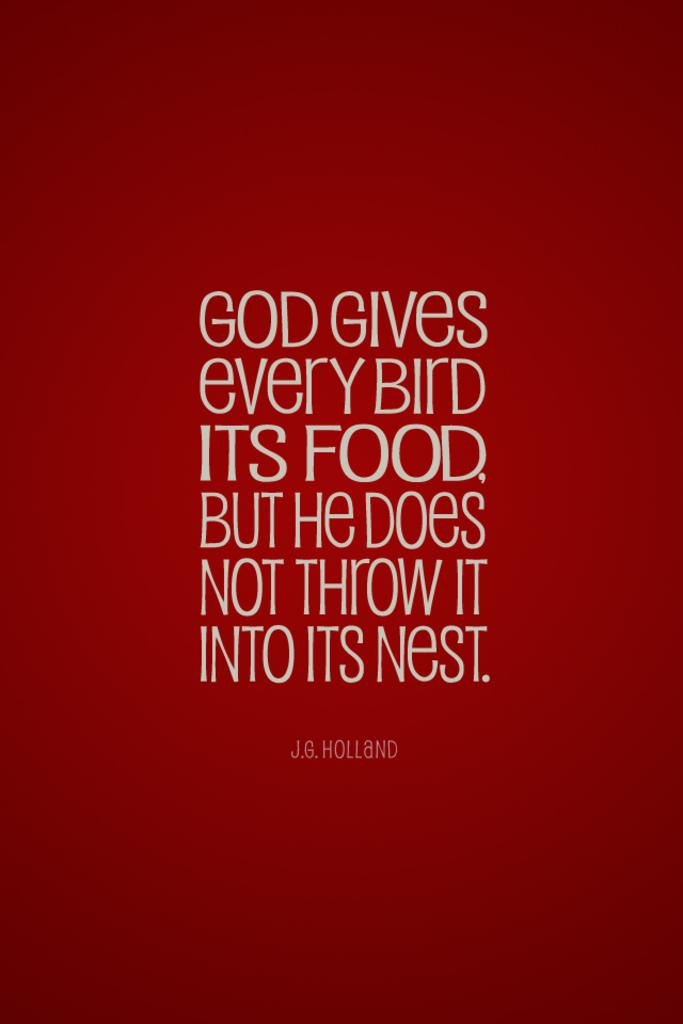What can be found in the image? There is text in the image. What type of knowledge can be gained from the account in the image? There is no account present in the image, only text. Therefore, it is not possible to determine what type of knowledge can be gained from it. 